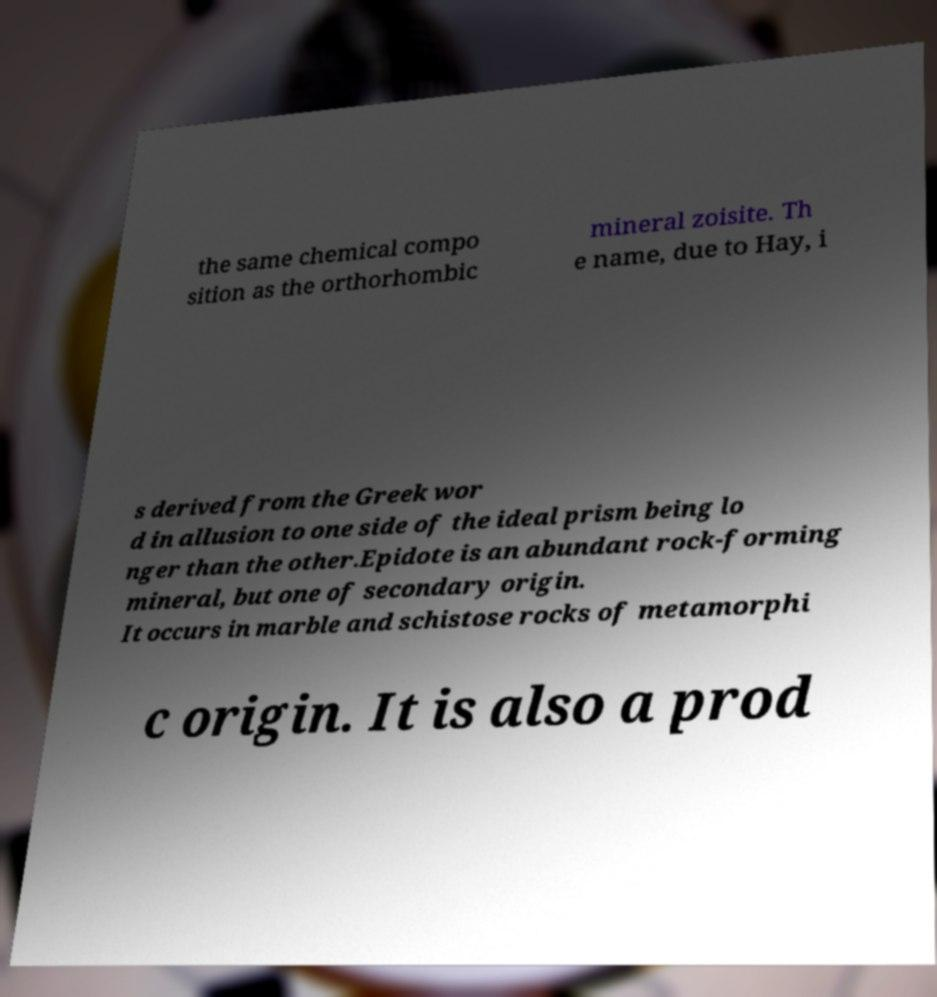For documentation purposes, I need the text within this image transcribed. Could you provide that? the same chemical compo sition as the orthorhombic mineral zoisite. Th e name, due to Hay, i s derived from the Greek wor d in allusion to one side of the ideal prism being lo nger than the other.Epidote is an abundant rock-forming mineral, but one of secondary origin. It occurs in marble and schistose rocks of metamorphi c origin. It is also a prod 